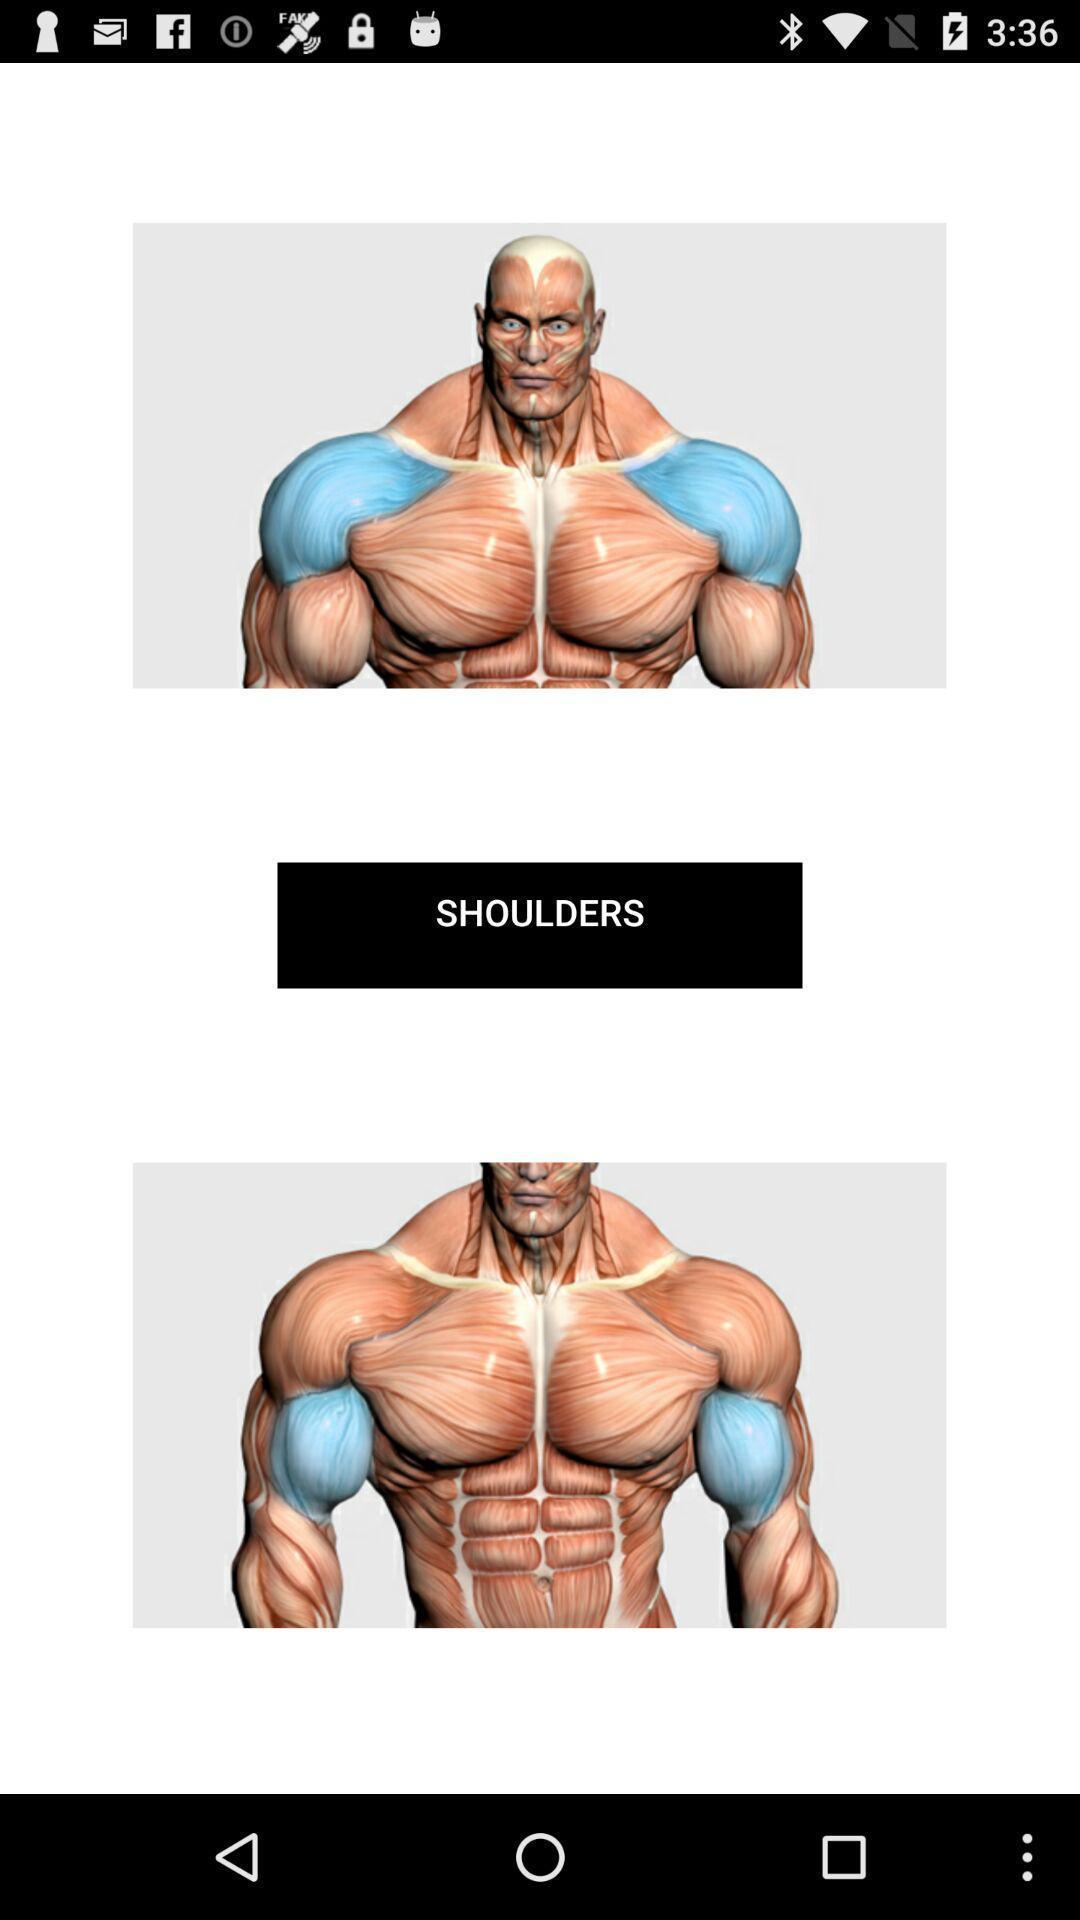Give me a narrative description of this picture. Page showing images of fitness app. 